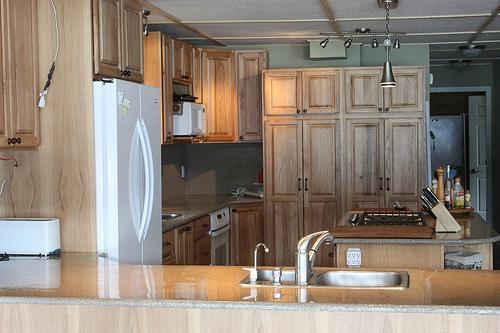How many microwaves are there?
Give a very brief answer. 1. 